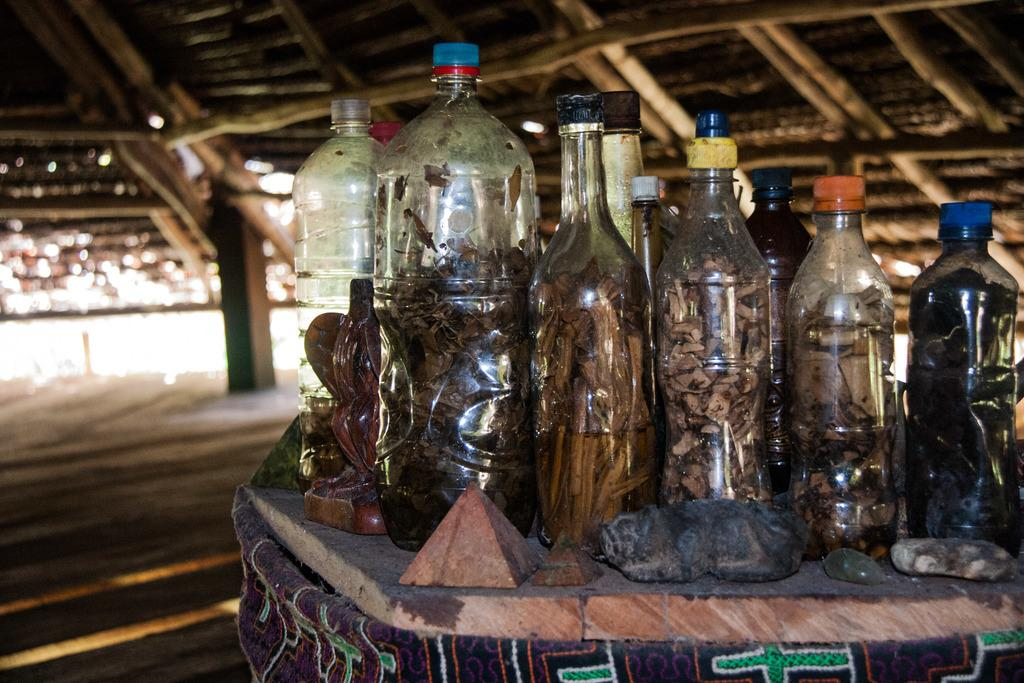What type of table is in the image? There is a wooden table in the image. What is on the table? There are bottles on the table. What can be found inside the bottles? There are things placed inside the bottles. How many hooks are hanging from the table in the image? There are no hooks hanging from the table in the image. 